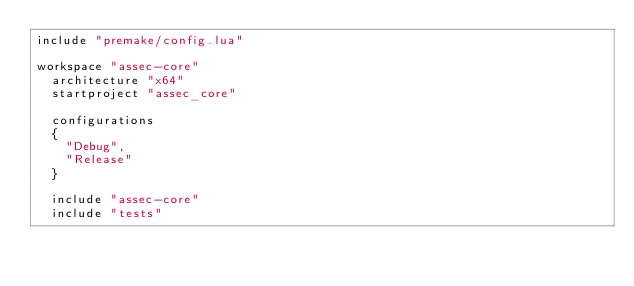Convert code to text. <code><loc_0><loc_0><loc_500><loc_500><_Lua_>include "premake/config.lua"

workspace "assec-core"
	architecture "x64"
	startproject "assec_core"

	configurations
	{
		"Debug",
		"Release"
	}

	include "assec-core"
	include "tests"</code> 